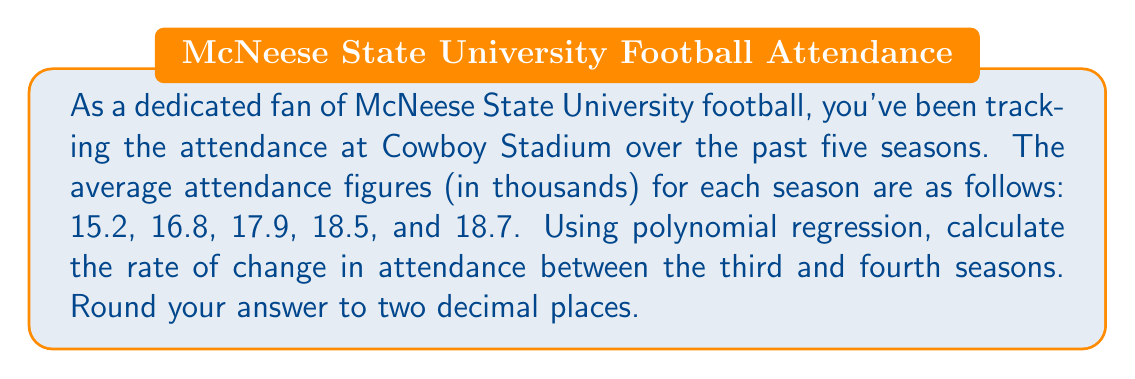Can you answer this question? To solve this problem, we'll use polynomial regression to fit a curve to the data and then calculate the rate of change between the third and fourth seasons.

1. Let's assign variables:
   $x$ represents the season number (1 to 5)
   $y$ represents the attendance in thousands

2. Our data points are:
   (1, 15.2), (2, 16.8), (3, 17.9), (4, 18.5), (5, 18.7)

3. We'll use a second-degree polynomial (quadratic) for this regression:
   $y = ax^2 + bx + c$

4. Using a polynomial regression calculator or software, we find the equation:
   $y = -0.3x^2 + 2.69x + 12.73$

5. To find the rate of change, we need to calculate the derivative of this function:
   $\frac{dy}{dx} = -0.6x + 2.69$

6. Now, we evaluate this derivative at $x = 3$ (third season) and $x = 4$ (fourth season):

   At $x = 3$: $\frac{dy}{dx} = -0.6(3) + 2.69 = 0.89$
   At $x = 4$: $\frac{dy}{dx} = -0.6(4) + 2.69 = 0.29$

7. The rate of change between these two seasons is the average of these values:
   $\frac{0.89 + 0.29}{2} = 0.59$

Therefore, the rate of change in attendance between the third and fourth seasons is approximately 0.59 thousand (or 590 fans) per season.
Answer: 0.59 